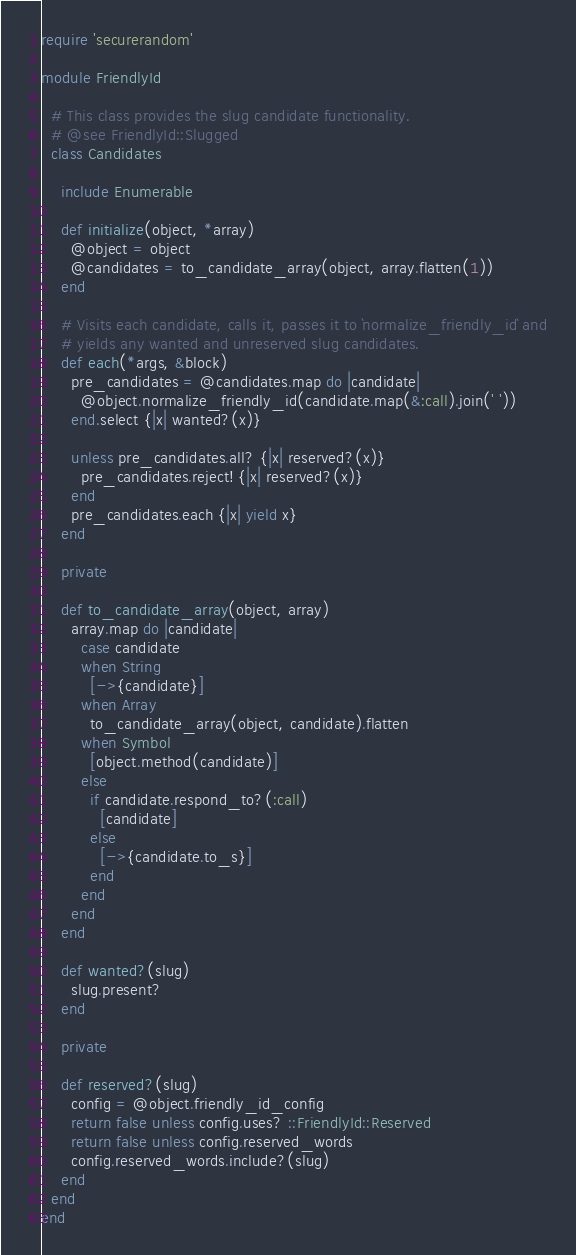Convert code to text. <code><loc_0><loc_0><loc_500><loc_500><_Ruby_>require 'securerandom'

module FriendlyId

  # This class provides the slug candidate functionality.
  # @see FriendlyId::Slugged
  class Candidates

    include Enumerable

    def initialize(object, *array)
      @object = object
      @candidates = to_candidate_array(object, array.flatten(1))
    end

    # Visits each candidate, calls it, passes it to `normalize_friendly_id` and
    # yields any wanted and unreserved slug candidates.
    def each(*args, &block)
      pre_candidates = @candidates.map do |candidate|
        @object.normalize_friendly_id(candidate.map(&:call).join(' '))
      end.select {|x| wanted?(x)}

      unless pre_candidates.all? {|x| reserved?(x)}
        pre_candidates.reject! {|x| reserved?(x)}
      end
      pre_candidates.each {|x| yield x}
    end

    private

    def to_candidate_array(object, array)
      array.map do |candidate|
        case candidate
        when String
          [->{candidate}]
        when Array
          to_candidate_array(object, candidate).flatten
        when Symbol
          [object.method(candidate)]
        else
          if candidate.respond_to?(:call)
            [candidate]
          else
            [->{candidate.to_s}]
          end
        end
      end
    end

    def wanted?(slug)
      slug.present?
    end

    private

    def reserved?(slug)
      config = @object.friendly_id_config
      return false unless config.uses? ::FriendlyId::Reserved
      return false unless config.reserved_words
      config.reserved_words.include?(slug)
    end
  end
end
</code> 